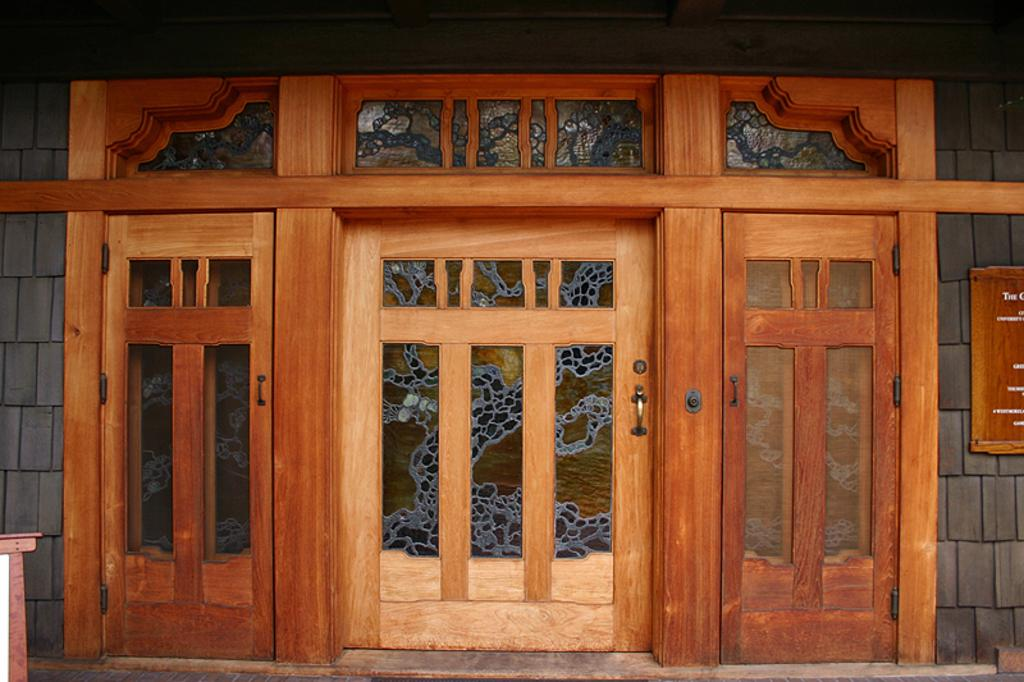What type of structure is present in the image? There are doors in the image. Where are the doors located? The doors are attached to a wall. What is located to the right of the doors? There is a wooden board to the right of the doors. What can be seen on the wooden board? Something is written on the wooden board. Can you describe the swing that is hanging from the hydrant in the image? There is no swing or hydrant present in the image; it only features doors, a wall, and a wooden board. 